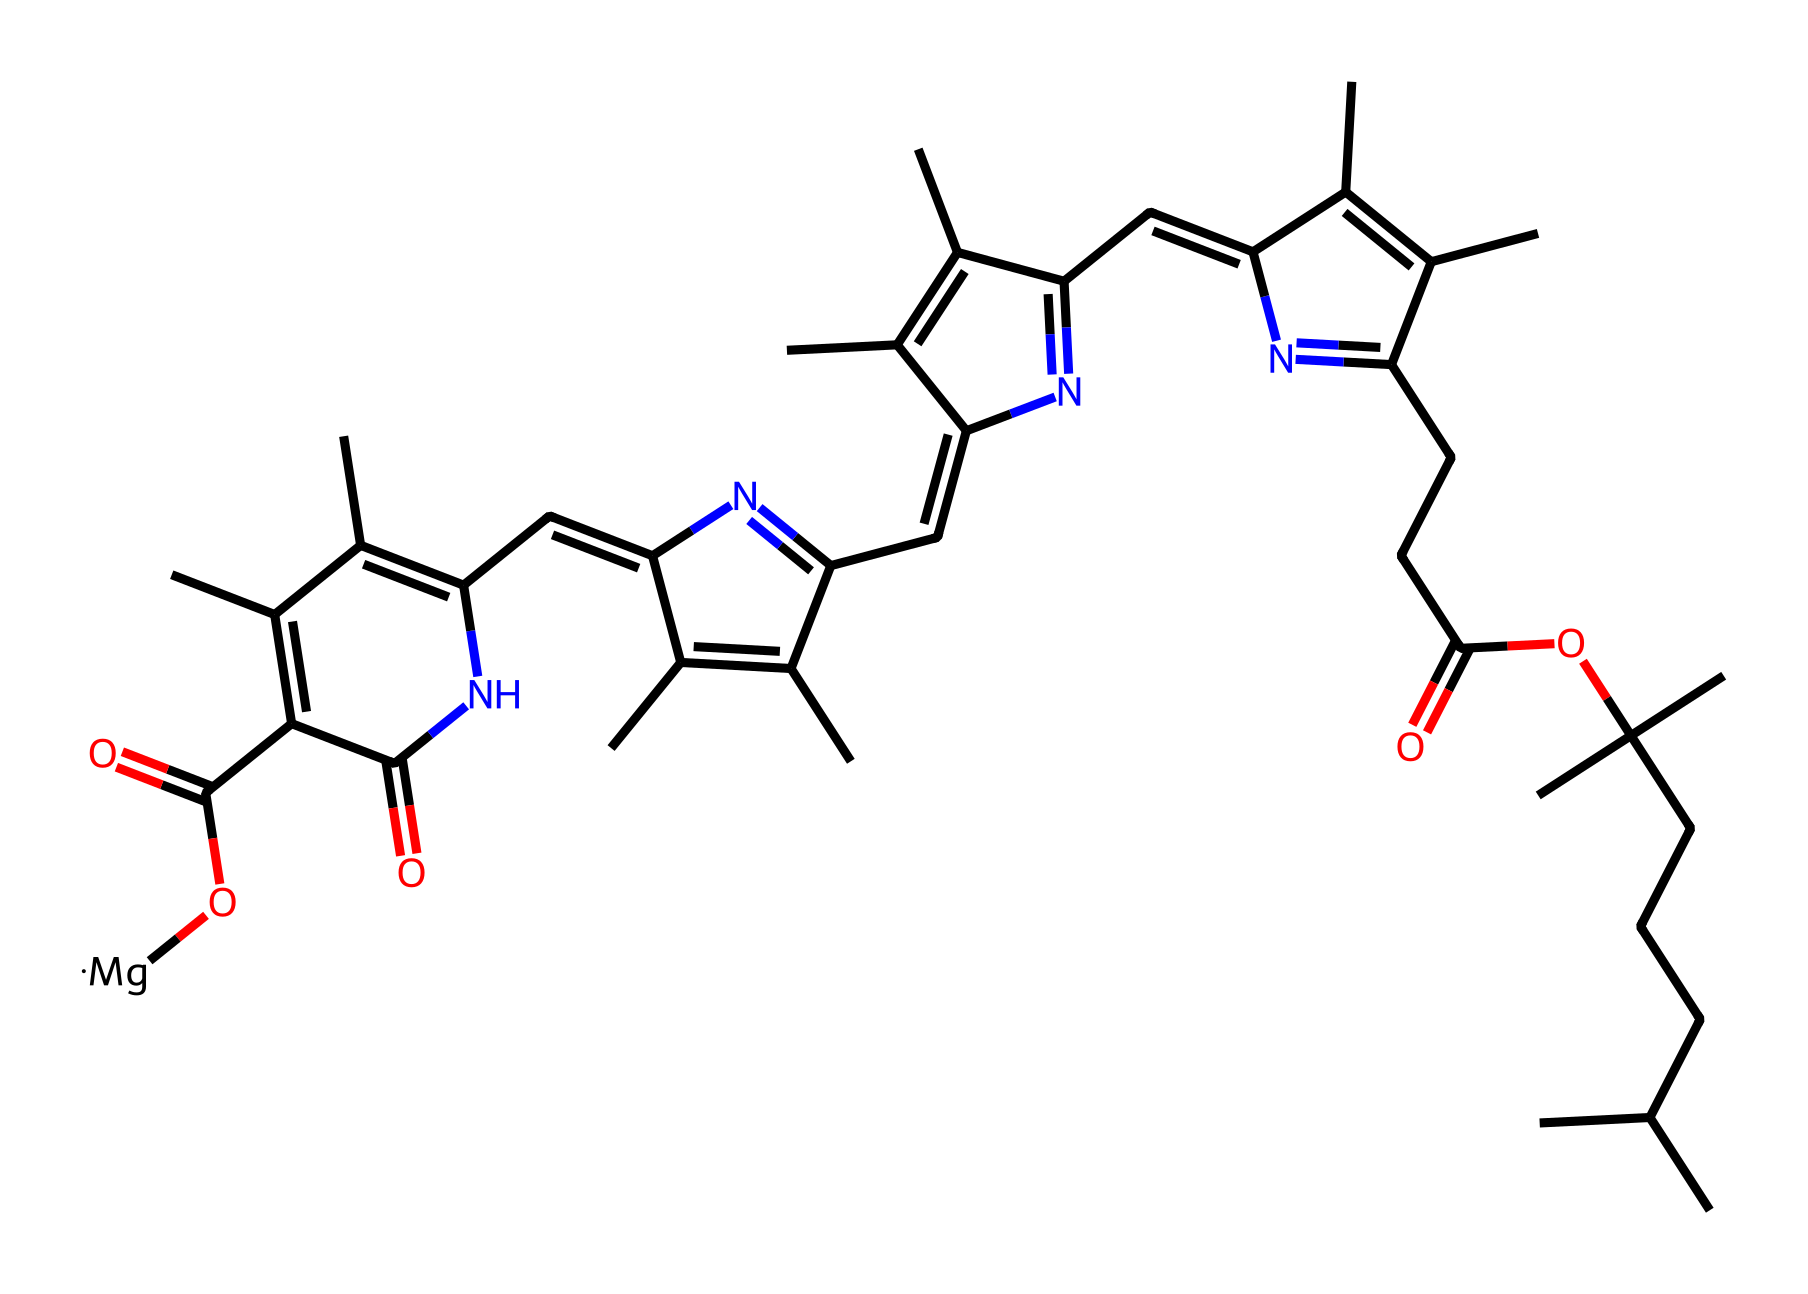What is the central metal atom in this chlorophyll structure? The chemical structure features a magnesium ion (indicated by "[Mg]"), which is central to the chlorophyll molecule's role in light absorption.
Answer: magnesium How many carbon atoms are present in this chlorophyll structure? By counting all the carbon atoms (C) in the SMILES representation, we find there are 20 carbon atoms total in the chlorophyll structure.
Answer: 20 What type of functional group is present in the chlorophyll structure indicated by "C(=O)"? The "C(=O)" notation indicates a carbonyl group, which is a functional group consisting of a carbon atom double-bonded to an oxygen atom.
Answer: carbonyl Which part of the chemical is responsible for light absorption? The conjugated double bond system within the cyclic structures of chlorophyll allows for light absorption, particularly in the regions of red and blue wavelengths.
Answer: conjugated system How many nitrogen atoms are part of the chlorophyll molecule? The SMILES representation contains four nitrogen atoms (N), each contributing to the conjugated system that facilitates electron delocalization.
Answer: 4 What is the role of the magnesium ion in chlorophyll? The magnesium ion coordinates with the carbonyl groups and is crucial for the molecule's ability to absorb light and transfer energy during photosynthesis.
Answer: light absorption Is this molecule hydrophilic or hydrophobic? The presence of long hydrocarbon chains suggests that this chlorophyll molecule is predominantly hydrophobic, making it less soluble in water.
Answer: hydrophobic 